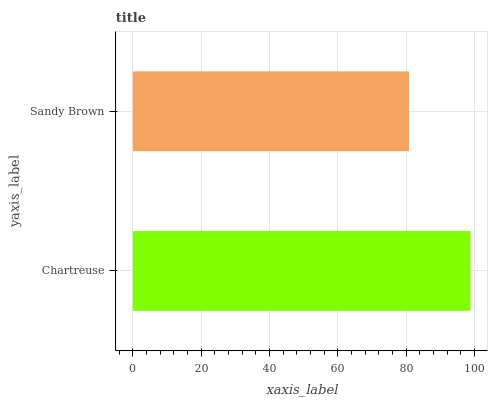Is Sandy Brown the minimum?
Answer yes or no. Yes. Is Chartreuse the maximum?
Answer yes or no. Yes. Is Sandy Brown the maximum?
Answer yes or no. No. Is Chartreuse greater than Sandy Brown?
Answer yes or no. Yes. Is Sandy Brown less than Chartreuse?
Answer yes or no. Yes. Is Sandy Brown greater than Chartreuse?
Answer yes or no. No. Is Chartreuse less than Sandy Brown?
Answer yes or no. No. Is Chartreuse the high median?
Answer yes or no. Yes. Is Sandy Brown the low median?
Answer yes or no. Yes. Is Sandy Brown the high median?
Answer yes or no. No. Is Chartreuse the low median?
Answer yes or no. No. 